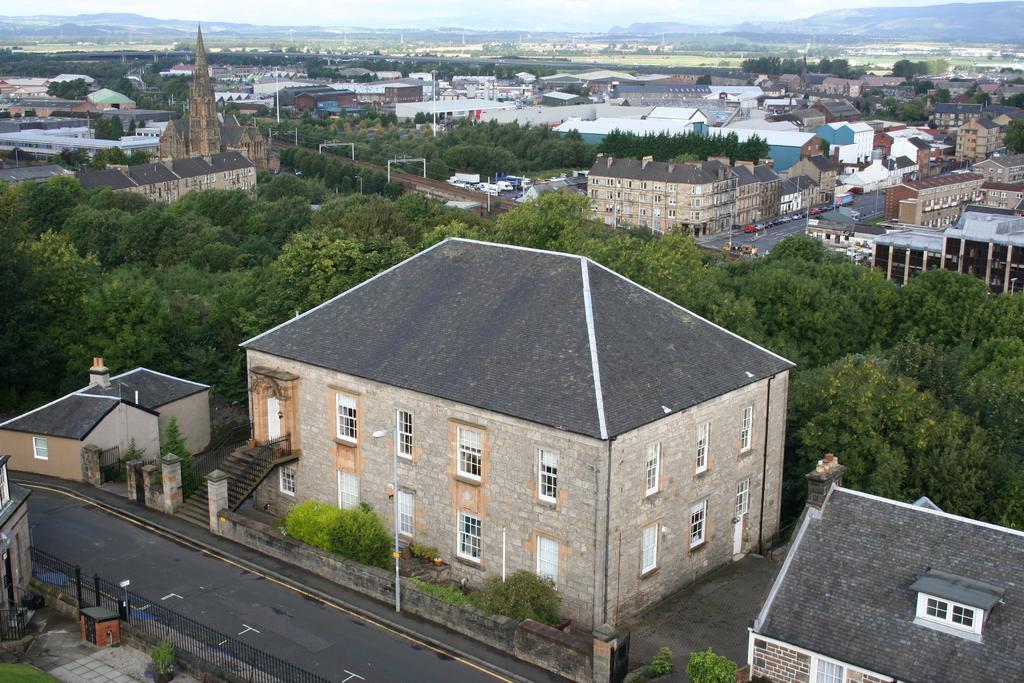Could you give a brief overview of what you see in this image? In the foreground of the picture there are plants, buildings, road, trees, railing and other objects. In the center of the picture there are trees, buildings, tracks and other objects. In the background there are trees, field, hills and sky. 